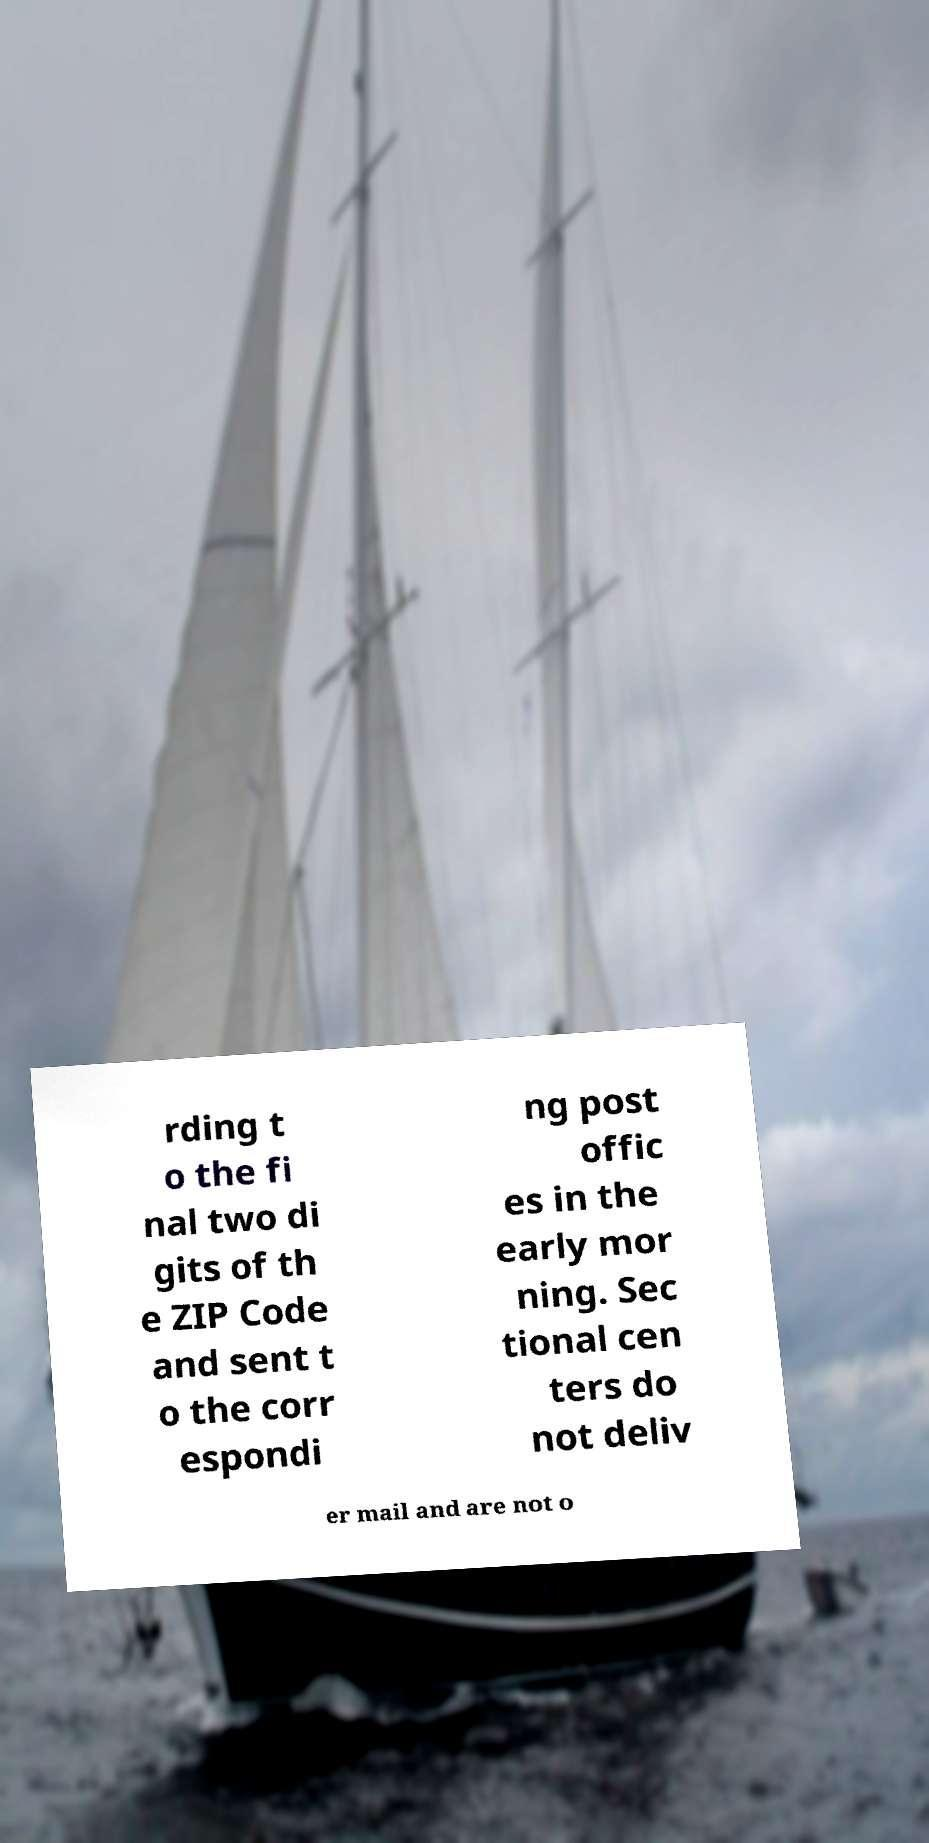Please identify and transcribe the text found in this image. rding t o the fi nal two di gits of th e ZIP Code and sent t o the corr espondi ng post offic es in the early mor ning. Sec tional cen ters do not deliv er mail and are not o 